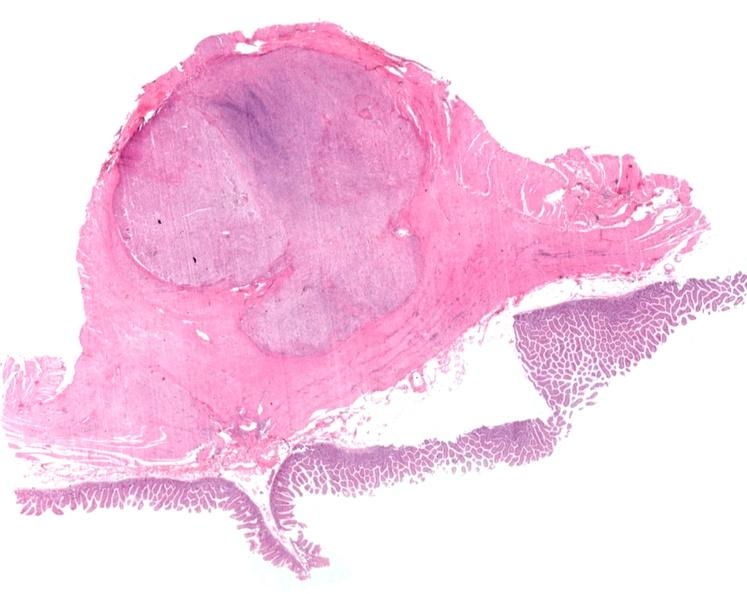does hemorrhage associated with placental abruption show stomach, leiomyoma with ulcerated mucosal surface?
Answer the question using a single word or phrase. No 